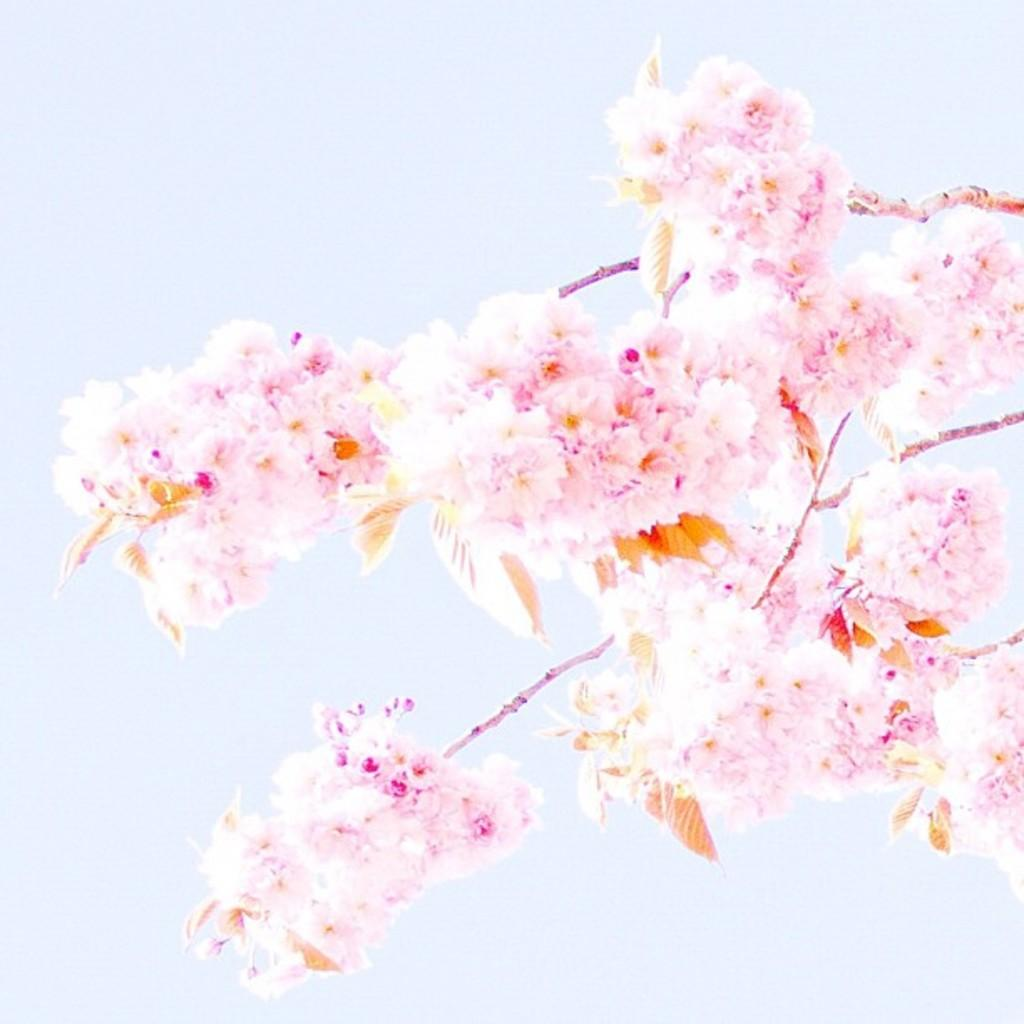What type of plants are in the image? There are flowers in the image. How are the flowers connected to their stems? The flowers are attached to stems. What can be seen in the background of the image? There is sky visible in the background of the image. What songs is the mother singing to the dolls in the image? There is no mother or dolls present in the image; it only features flowers and sky. 